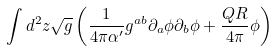Convert formula to latex. <formula><loc_0><loc_0><loc_500><loc_500>\int d ^ { 2 } z \sqrt { g } \left ( \frac { 1 } { 4 \pi \alpha ^ { \prime } } g ^ { a b } \partial _ { a } \phi \partial _ { b } \phi + \frac { Q R } { 4 \pi } \phi \right )</formula> 